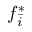<formula> <loc_0><loc_0><loc_500><loc_500>f _ { \bar { i } } ^ { * }</formula> 